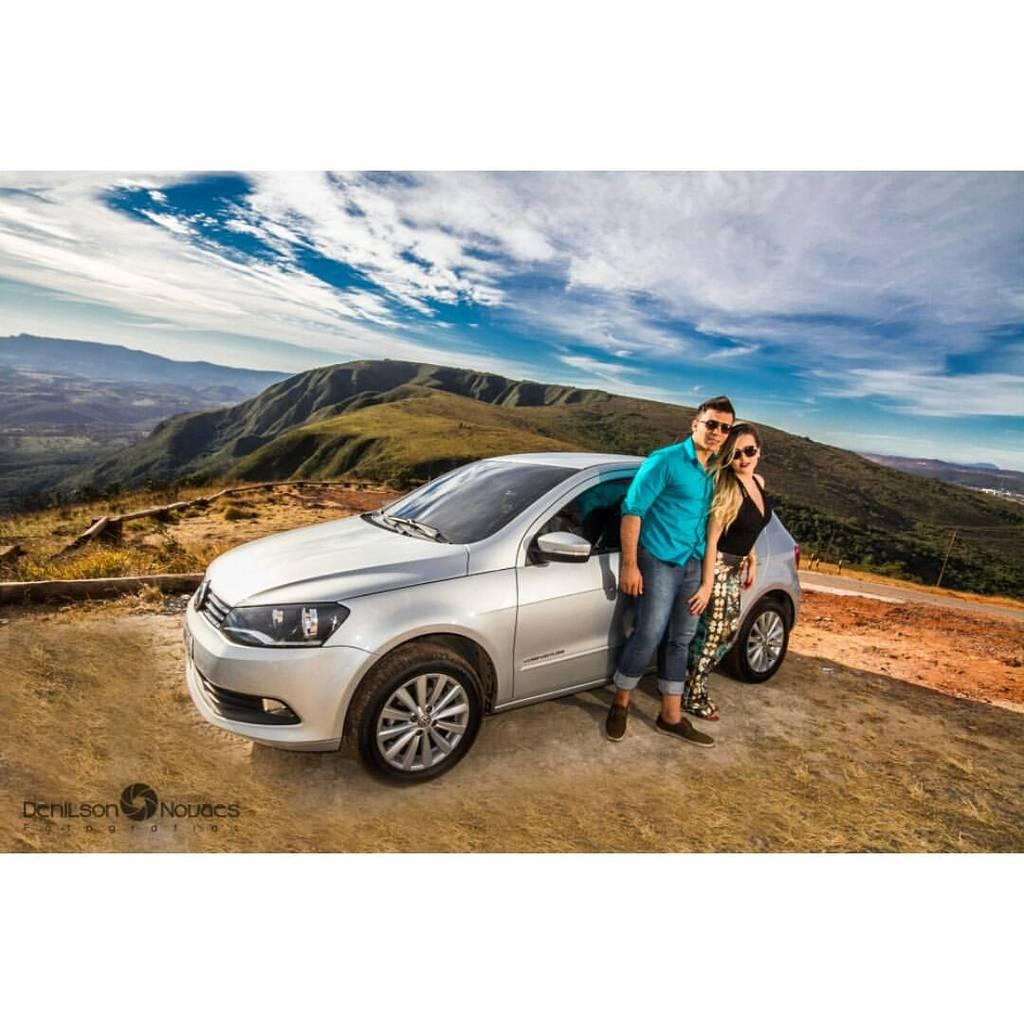How many people are in the image? There is a man and a woman in the image. What are the man and woman doing in the image? The man and woman are standing near a car. Can you describe the car in the image? The car is gray in color. What can be seen in the background of the image? There is grass, hills, and the sky visible in the background of the image. What is the condition of the sky in the image? Clouds are present in the sky. Where is the basketball located in the image? There is no basketball present in the image. What type of table can be seen in the image? There is no table present in the image. 